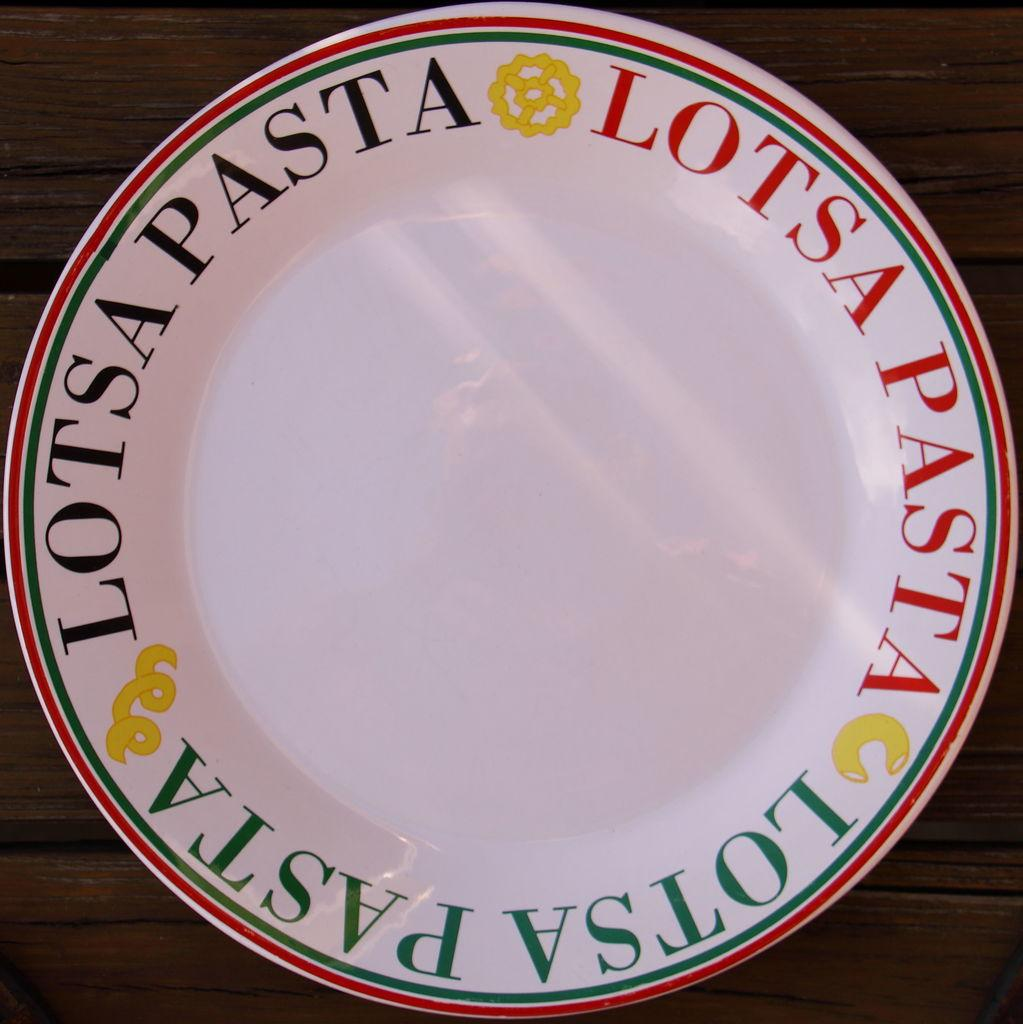What is the main feature of the image? There is a white area in the image. What can be found on the edges of the white area? The edges of the white area have text. What type of surface is the white area placed on? The white area is placed on a wooden surface. Where is the kitty hiding in the image? There is no kitty present in the image. What type of tin can be seen in the image? There is no tin present in the image. 